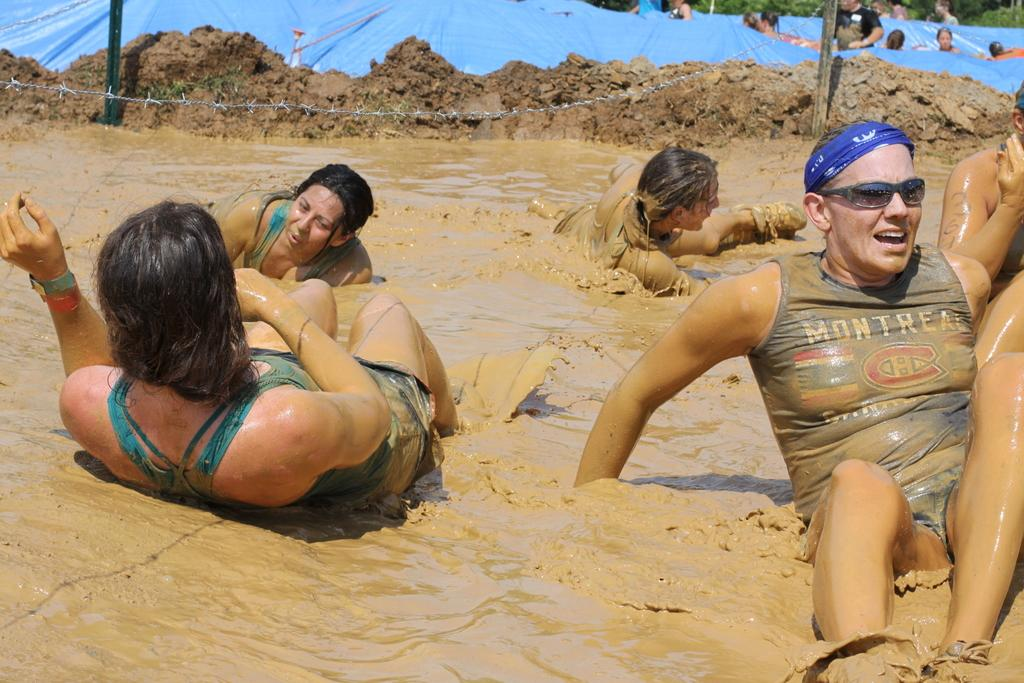What substance is present in the image? There is mud in the image. What can be seen in the mud in the image? There are people on the mud in the image. What type of sack can be seen being carried by the people in the image? There is no sack present in the image. What direction are the people in the image looking? The facts provided do not mention the direction the people are looking. Is there a gun visible in the image? There is no gun present in the image. 